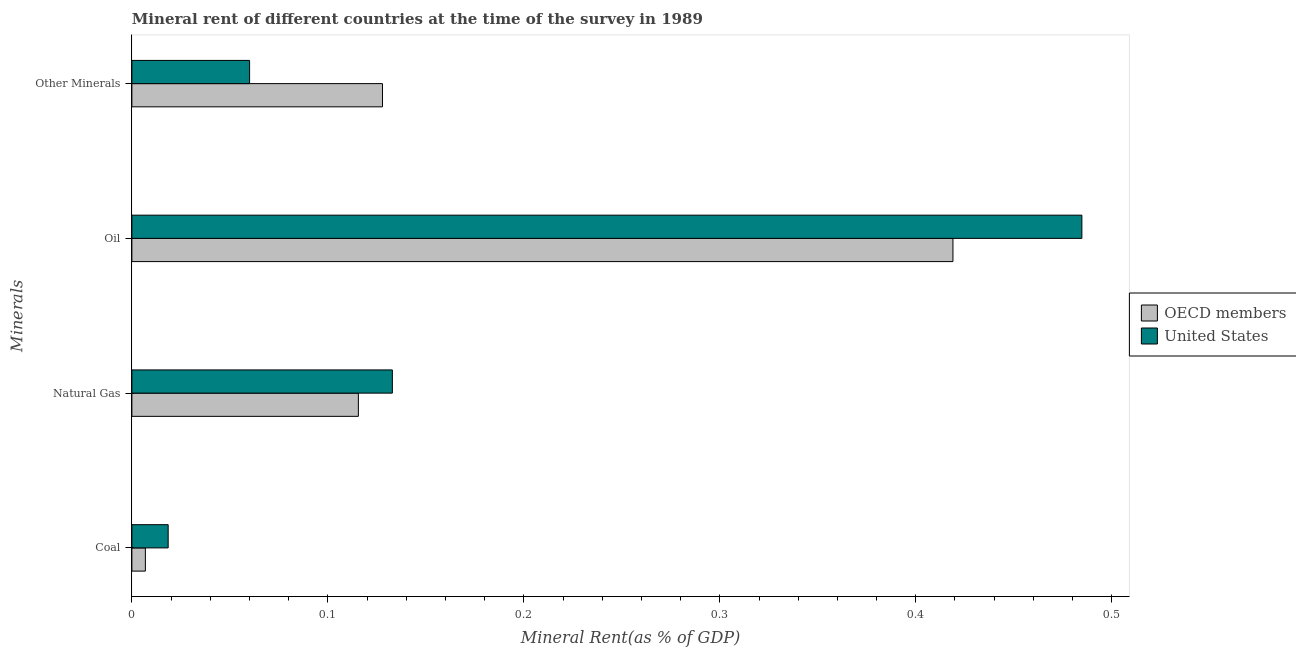Are the number of bars per tick equal to the number of legend labels?
Provide a succinct answer. Yes. How many bars are there on the 1st tick from the bottom?
Offer a very short reply. 2. What is the label of the 2nd group of bars from the top?
Provide a succinct answer. Oil. What is the oil rent in OECD members?
Your answer should be compact. 0.42. Across all countries, what is the maximum coal rent?
Keep it short and to the point. 0.02. Across all countries, what is the minimum  rent of other minerals?
Offer a very short reply. 0.06. In which country was the natural gas rent maximum?
Ensure brevity in your answer.  United States. In which country was the oil rent minimum?
Make the answer very short. OECD members. What is the total  rent of other minerals in the graph?
Ensure brevity in your answer.  0.19. What is the difference between the  rent of other minerals in OECD members and that in United States?
Provide a short and direct response. 0.07. What is the difference between the oil rent in United States and the  rent of other minerals in OECD members?
Ensure brevity in your answer.  0.36. What is the average natural gas rent per country?
Your answer should be compact. 0.12. What is the difference between the coal rent and  rent of other minerals in United States?
Your answer should be compact. -0.04. In how many countries, is the  rent of other minerals greater than 0.32000000000000006 %?
Ensure brevity in your answer.  0. What is the ratio of the coal rent in OECD members to that in United States?
Provide a succinct answer. 0.37. Is the oil rent in United States less than that in OECD members?
Provide a succinct answer. No. Is the difference between the coal rent in OECD members and United States greater than the difference between the  rent of other minerals in OECD members and United States?
Keep it short and to the point. No. What is the difference between the highest and the second highest coal rent?
Offer a terse response. 0.01. What is the difference between the highest and the lowest coal rent?
Your answer should be compact. 0.01. In how many countries, is the  rent of other minerals greater than the average  rent of other minerals taken over all countries?
Your answer should be very brief. 1. Is the sum of the coal rent in OECD members and United States greater than the maximum oil rent across all countries?
Provide a short and direct response. No. What does the 1st bar from the bottom in Oil represents?
Your answer should be very brief. OECD members. Are all the bars in the graph horizontal?
Your response must be concise. Yes. What is the difference between two consecutive major ticks on the X-axis?
Give a very brief answer. 0.1. Does the graph contain any zero values?
Your answer should be very brief. No. Does the graph contain grids?
Your response must be concise. No. Where does the legend appear in the graph?
Offer a very short reply. Center right. How are the legend labels stacked?
Offer a terse response. Vertical. What is the title of the graph?
Offer a very short reply. Mineral rent of different countries at the time of the survey in 1989. Does "West Bank and Gaza" appear as one of the legend labels in the graph?
Your response must be concise. No. What is the label or title of the X-axis?
Provide a succinct answer. Mineral Rent(as % of GDP). What is the label or title of the Y-axis?
Offer a terse response. Minerals. What is the Mineral Rent(as % of GDP) of OECD members in Coal?
Make the answer very short. 0.01. What is the Mineral Rent(as % of GDP) in United States in Coal?
Keep it short and to the point. 0.02. What is the Mineral Rent(as % of GDP) of OECD members in Natural Gas?
Ensure brevity in your answer.  0.12. What is the Mineral Rent(as % of GDP) in United States in Natural Gas?
Provide a succinct answer. 0.13. What is the Mineral Rent(as % of GDP) in OECD members in Oil?
Your answer should be compact. 0.42. What is the Mineral Rent(as % of GDP) in United States in Oil?
Make the answer very short. 0.48. What is the Mineral Rent(as % of GDP) of OECD members in Other Minerals?
Make the answer very short. 0.13. What is the Mineral Rent(as % of GDP) of United States in Other Minerals?
Keep it short and to the point. 0.06. Across all Minerals, what is the maximum Mineral Rent(as % of GDP) in OECD members?
Give a very brief answer. 0.42. Across all Minerals, what is the maximum Mineral Rent(as % of GDP) in United States?
Ensure brevity in your answer.  0.48. Across all Minerals, what is the minimum Mineral Rent(as % of GDP) in OECD members?
Offer a terse response. 0.01. Across all Minerals, what is the minimum Mineral Rent(as % of GDP) in United States?
Make the answer very short. 0.02. What is the total Mineral Rent(as % of GDP) in OECD members in the graph?
Keep it short and to the point. 0.67. What is the total Mineral Rent(as % of GDP) in United States in the graph?
Provide a short and direct response. 0.7. What is the difference between the Mineral Rent(as % of GDP) in OECD members in Coal and that in Natural Gas?
Your answer should be very brief. -0.11. What is the difference between the Mineral Rent(as % of GDP) in United States in Coal and that in Natural Gas?
Offer a terse response. -0.11. What is the difference between the Mineral Rent(as % of GDP) of OECD members in Coal and that in Oil?
Keep it short and to the point. -0.41. What is the difference between the Mineral Rent(as % of GDP) in United States in Coal and that in Oil?
Ensure brevity in your answer.  -0.47. What is the difference between the Mineral Rent(as % of GDP) of OECD members in Coal and that in Other Minerals?
Provide a succinct answer. -0.12. What is the difference between the Mineral Rent(as % of GDP) in United States in Coal and that in Other Minerals?
Give a very brief answer. -0.04. What is the difference between the Mineral Rent(as % of GDP) of OECD members in Natural Gas and that in Oil?
Your answer should be very brief. -0.3. What is the difference between the Mineral Rent(as % of GDP) of United States in Natural Gas and that in Oil?
Offer a terse response. -0.35. What is the difference between the Mineral Rent(as % of GDP) of OECD members in Natural Gas and that in Other Minerals?
Provide a short and direct response. -0.01. What is the difference between the Mineral Rent(as % of GDP) in United States in Natural Gas and that in Other Minerals?
Keep it short and to the point. 0.07. What is the difference between the Mineral Rent(as % of GDP) of OECD members in Oil and that in Other Minerals?
Provide a succinct answer. 0.29. What is the difference between the Mineral Rent(as % of GDP) in United States in Oil and that in Other Minerals?
Offer a terse response. 0.42. What is the difference between the Mineral Rent(as % of GDP) in OECD members in Coal and the Mineral Rent(as % of GDP) in United States in Natural Gas?
Ensure brevity in your answer.  -0.13. What is the difference between the Mineral Rent(as % of GDP) of OECD members in Coal and the Mineral Rent(as % of GDP) of United States in Oil?
Make the answer very short. -0.48. What is the difference between the Mineral Rent(as % of GDP) in OECD members in Coal and the Mineral Rent(as % of GDP) in United States in Other Minerals?
Offer a very short reply. -0.05. What is the difference between the Mineral Rent(as % of GDP) of OECD members in Natural Gas and the Mineral Rent(as % of GDP) of United States in Oil?
Keep it short and to the point. -0.37. What is the difference between the Mineral Rent(as % of GDP) of OECD members in Natural Gas and the Mineral Rent(as % of GDP) of United States in Other Minerals?
Your answer should be very brief. 0.06. What is the difference between the Mineral Rent(as % of GDP) of OECD members in Oil and the Mineral Rent(as % of GDP) of United States in Other Minerals?
Your answer should be compact. 0.36. What is the average Mineral Rent(as % of GDP) of OECD members per Minerals?
Ensure brevity in your answer.  0.17. What is the average Mineral Rent(as % of GDP) of United States per Minerals?
Offer a very short reply. 0.17. What is the difference between the Mineral Rent(as % of GDP) in OECD members and Mineral Rent(as % of GDP) in United States in Coal?
Your response must be concise. -0.01. What is the difference between the Mineral Rent(as % of GDP) in OECD members and Mineral Rent(as % of GDP) in United States in Natural Gas?
Make the answer very short. -0.02. What is the difference between the Mineral Rent(as % of GDP) in OECD members and Mineral Rent(as % of GDP) in United States in Oil?
Your response must be concise. -0.07. What is the difference between the Mineral Rent(as % of GDP) in OECD members and Mineral Rent(as % of GDP) in United States in Other Minerals?
Ensure brevity in your answer.  0.07. What is the ratio of the Mineral Rent(as % of GDP) of OECD members in Coal to that in Natural Gas?
Make the answer very short. 0.06. What is the ratio of the Mineral Rent(as % of GDP) in United States in Coal to that in Natural Gas?
Your response must be concise. 0.14. What is the ratio of the Mineral Rent(as % of GDP) of OECD members in Coal to that in Oil?
Give a very brief answer. 0.02. What is the ratio of the Mineral Rent(as % of GDP) in United States in Coal to that in Oil?
Offer a very short reply. 0.04. What is the ratio of the Mineral Rent(as % of GDP) in OECD members in Coal to that in Other Minerals?
Your answer should be very brief. 0.05. What is the ratio of the Mineral Rent(as % of GDP) in United States in Coal to that in Other Minerals?
Make the answer very short. 0.31. What is the ratio of the Mineral Rent(as % of GDP) in OECD members in Natural Gas to that in Oil?
Your response must be concise. 0.28. What is the ratio of the Mineral Rent(as % of GDP) of United States in Natural Gas to that in Oil?
Your answer should be very brief. 0.27. What is the ratio of the Mineral Rent(as % of GDP) of OECD members in Natural Gas to that in Other Minerals?
Your answer should be compact. 0.9. What is the ratio of the Mineral Rent(as % of GDP) in United States in Natural Gas to that in Other Minerals?
Keep it short and to the point. 2.21. What is the ratio of the Mineral Rent(as % of GDP) in OECD members in Oil to that in Other Minerals?
Make the answer very short. 3.28. What is the ratio of the Mineral Rent(as % of GDP) of United States in Oil to that in Other Minerals?
Give a very brief answer. 8.07. What is the difference between the highest and the second highest Mineral Rent(as % of GDP) in OECD members?
Your response must be concise. 0.29. What is the difference between the highest and the second highest Mineral Rent(as % of GDP) in United States?
Offer a very short reply. 0.35. What is the difference between the highest and the lowest Mineral Rent(as % of GDP) in OECD members?
Your response must be concise. 0.41. What is the difference between the highest and the lowest Mineral Rent(as % of GDP) of United States?
Your answer should be very brief. 0.47. 